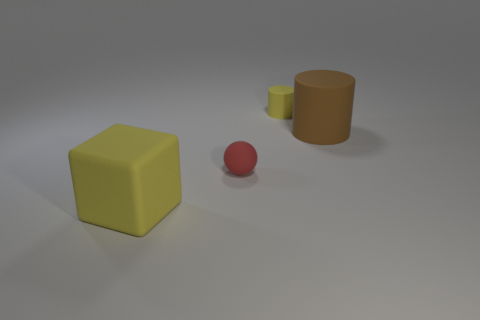There is a yellow object that is in front of the big object to the right of the yellow matte block; how big is it?
Your answer should be compact. Large. Is there a big yellow object that has the same material as the big cylinder?
Give a very brief answer. Yes. The matte thing to the right of the cylinder that is behind the object right of the tiny yellow matte thing is what shape?
Ensure brevity in your answer.  Cylinder. There is a large thing to the left of the tiny yellow rubber cylinder; is its color the same as the small thing that is behind the small red rubber sphere?
Your answer should be very brief. Yes. There is a tiny red matte thing; are there any tiny matte cylinders behind it?
Give a very brief answer. Yes. How many tiny things are the same shape as the big brown matte thing?
Offer a terse response. 1. What color is the small object that is in front of the yellow rubber thing that is to the right of the tiny matte object that is on the left side of the tiny yellow cylinder?
Provide a succinct answer. Red. Does the large object that is behind the rubber cube have the same material as the yellow thing that is on the right side of the red matte object?
Your answer should be compact. Yes. How many objects are either matte things on the left side of the tiny yellow thing or small yellow matte objects?
Offer a very short reply. 3. How many things are tiny gray metallic cylinders or large matte objects on the right side of the yellow matte block?
Provide a succinct answer. 1. 